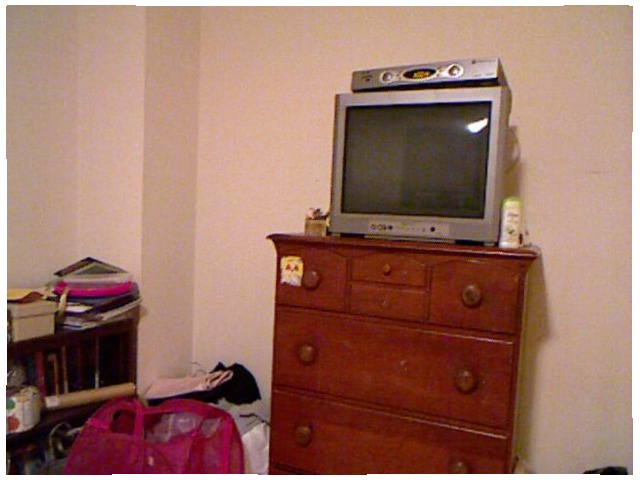<image>
Can you confirm if the television is on the stand? Yes. Looking at the image, I can see the television is positioned on top of the stand, with the stand providing support. Is the television on the cupboard? Yes. Looking at the image, I can see the television is positioned on top of the cupboard, with the cupboard providing support. Is there a cable box on the television? Yes. Looking at the image, I can see the cable box is positioned on top of the television, with the television providing support. Is there a tv under the cloth? No. The tv is not positioned under the cloth. The vertical relationship between these objects is different. Where is the tv in relation to the vcd? Is it next to the vcd? No. The tv is not positioned next to the vcd. They are located in different areas of the scene. 